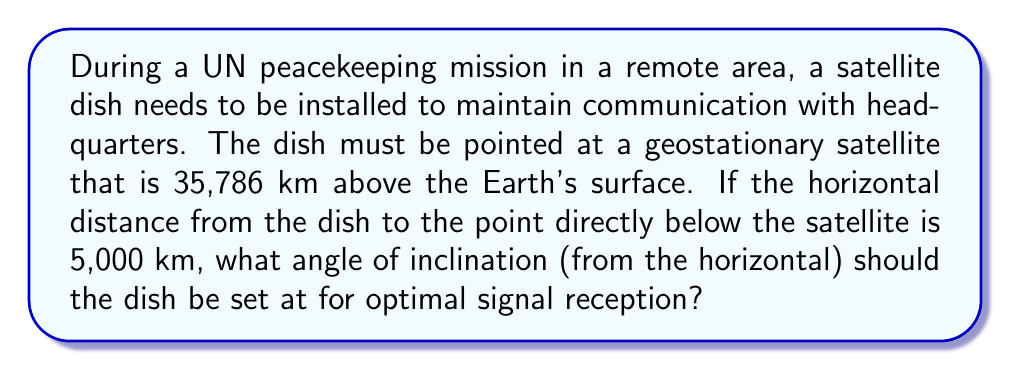What is the answer to this math problem? Let's approach this step-by-step using trigonometry:

1) We can visualize this scenario as a right triangle, where:
   - The base is the horizontal distance to the point below the satellite (5,000 km)
   - The height is the satellite's altitude (35,786 km)
   - The hypotenuse is the line of sight from the dish to the satellite
   - The angle we're looking for is the one between the base and the hypotenuse

2) We can use the arctangent function to find this angle. The tangent of an angle in a right triangle is the opposite side divided by the adjacent side.

3) In this case:
   - Opposite side = 35,786 km (satellite altitude)
   - Adjacent side = 5,000 km (horizontal distance)

4) Let $\theta$ be the angle of inclination. Then:

   $$\tan(\theta) = \frac{\text{opposite}}{\text{adjacent}} = \frac{35,786}{5,000}$$

5) To find $\theta$, we take the arctangent (or inverse tangent) of both sides:

   $$\theta = \arctan\left(\frac{35,786}{5,000}\right)$$

6) Using a calculator or computer:

   $$\theta \approx 82.0558^\circ$$

7) Round to two decimal places for practical application.
Answer: $82.06^\circ$ 